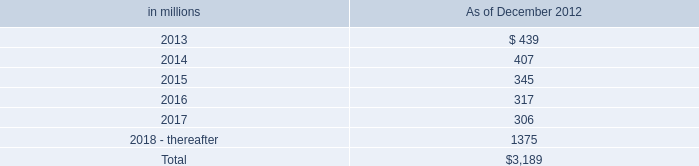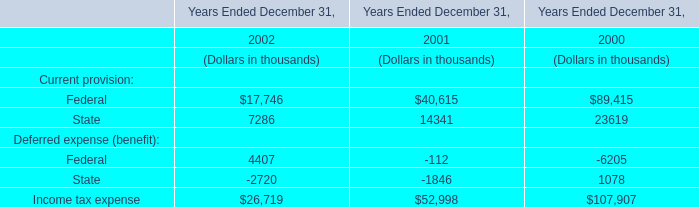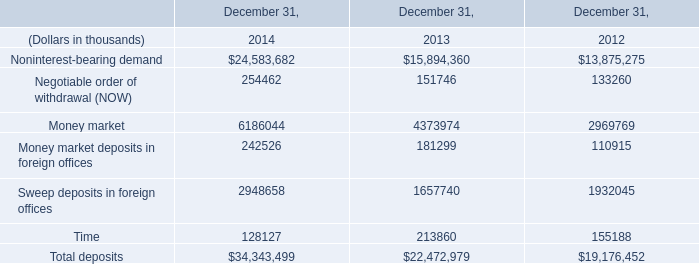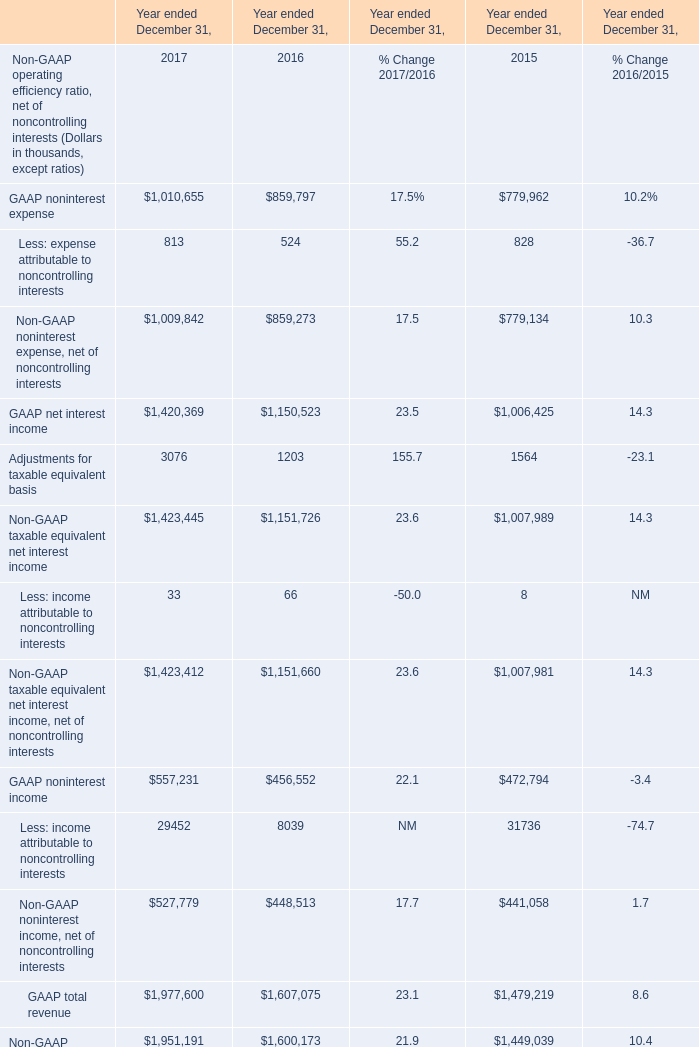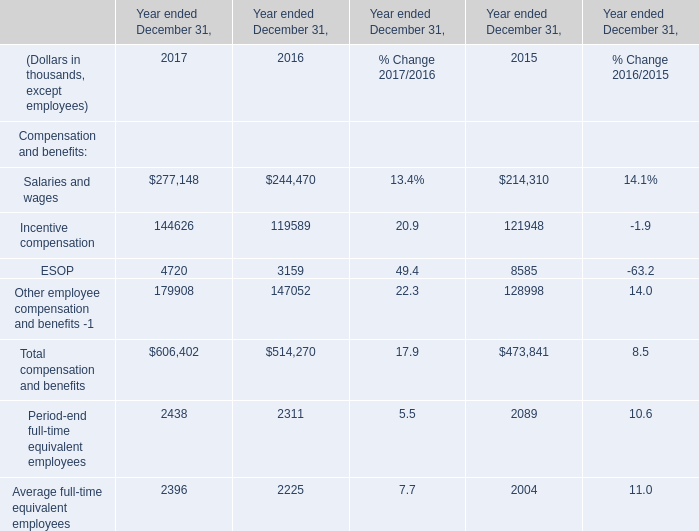Which year is Non-GAAP taxable equivalent net interest income the most? 
Answer: 2017. 